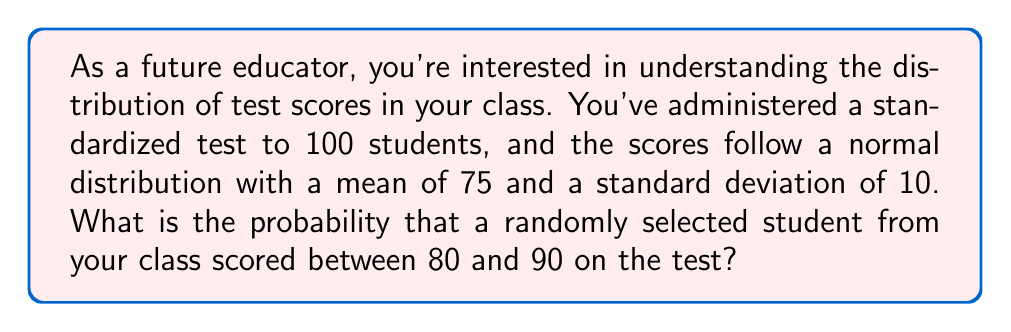Give your solution to this math problem. Let's approach this step-by-step:

1) First, we need to understand that we're dealing with a normal distribution. The random variable X represents the test scores, and we're given:
   $X \sim N(\mu = 75, \sigma = 10)$

2) We want to find $P(80 \leq X \leq 90)$

3) To solve this, we need to standardize these values using the z-score formula:
   $z = \frac{x - \mu}{\sigma}$

4) For the lower bound (80):
   $z_1 = \frac{80 - 75}{10} = 0.5$

5) For the upper bound (90):
   $z_2 = \frac{90 - 75}{10} = 1.5$

6) Now, we need to find $P(0.5 \leq Z \leq 1.5)$, where Z is the standard normal variable

7) This can be rewritten as:
   $P(Z \leq 1.5) - P(Z \leq 0.5)$

8) Using a standard normal table or calculator:
   $P(Z \leq 1.5) \approx 0.9332$
   $P(Z \leq 0.5) \approx 0.6915$

9) Therefore:
   $P(0.5 \leq Z \leq 1.5) = 0.9332 - 0.6915 = 0.2417$

10) This means there's approximately a 24.17% chance that a randomly selected student scored between 80 and 90 on the test.
Answer: 0.2417 or 24.17% 